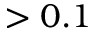<formula> <loc_0><loc_0><loc_500><loc_500>> 0 . 1</formula> 